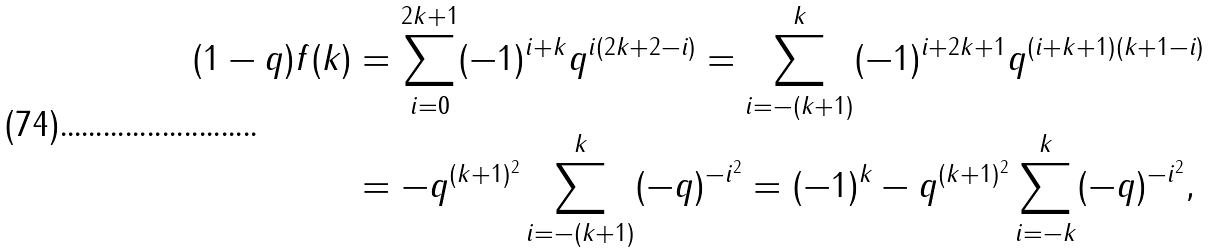Convert formula to latex. <formula><loc_0><loc_0><loc_500><loc_500>( 1 - q ) f ( k ) & = \sum _ { i = 0 } ^ { 2 k + 1 } ( - 1 ) ^ { i + k } q ^ { i ( 2 k + 2 - i ) } = \sum _ { i = - ( k + 1 ) } ^ { k } ( - 1 ) ^ { i + 2 k + 1 } q ^ { ( i + k + 1 ) ( k + 1 - i ) } \\ & = - q ^ { ( k + 1 ) ^ { 2 } } \sum _ { i = - ( k + 1 ) } ^ { k } ( - q ) ^ { - i ^ { 2 } } = ( - 1 ) ^ { k } - q ^ { ( k + 1 ) ^ { 2 } } \sum _ { i = - k } ^ { k } ( - q ) ^ { - i ^ { 2 } } ,</formula> 